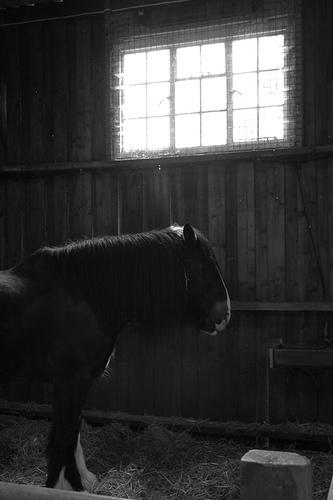Is day or night?
Short answer required. Day. Why are there animals here?
Quick response, please. Shelter. Is the horse alone?
Quick response, please. Yes. What animal is in the picture?
Be succinct. Horse. What is the building made out of?
Answer briefly. Wood. Is the wall made of wood?
Write a very short answer. Yes. What time of the day is it?
Write a very short answer. Afternoon. 